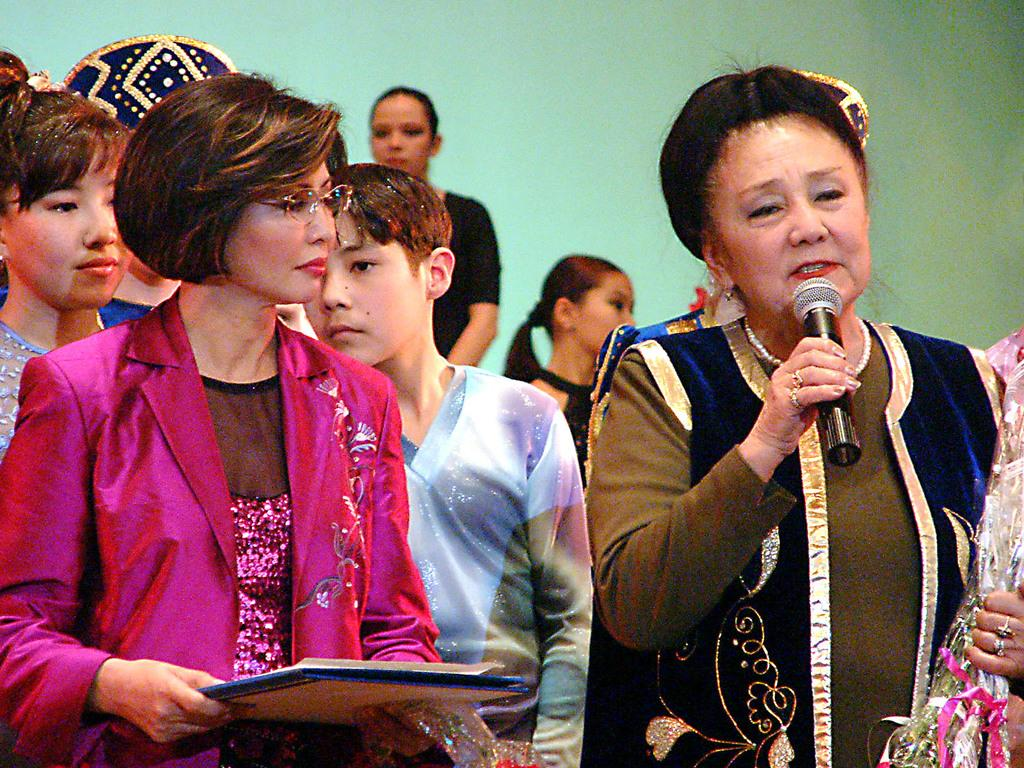How many people are in the image? There is a group of people in the image, but the exact number is not specified. What is the woman holding in the image? The woman is holding a microphone. What color is the wall in the background of the image? There is a green wall in the background of the image. Can you tell me how many decisions were made by the lake in the image? There is no lake present in the image, and therefore no decisions can be made by it. 